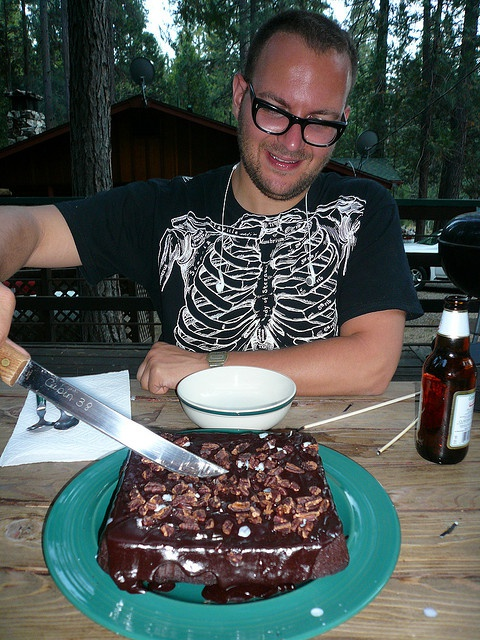Describe the objects in this image and their specific colors. I can see dining table in darkgreen, black, gray, teal, and white tones, people in darkgreen, black, brown, gray, and lightgray tones, cake in darkgreen, black, maroon, gray, and brown tones, bottle in darkgreen, black, white, maroon, and gray tones, and bowl in darkgreen, white, darkgray, teal, and gray tones in this image. 